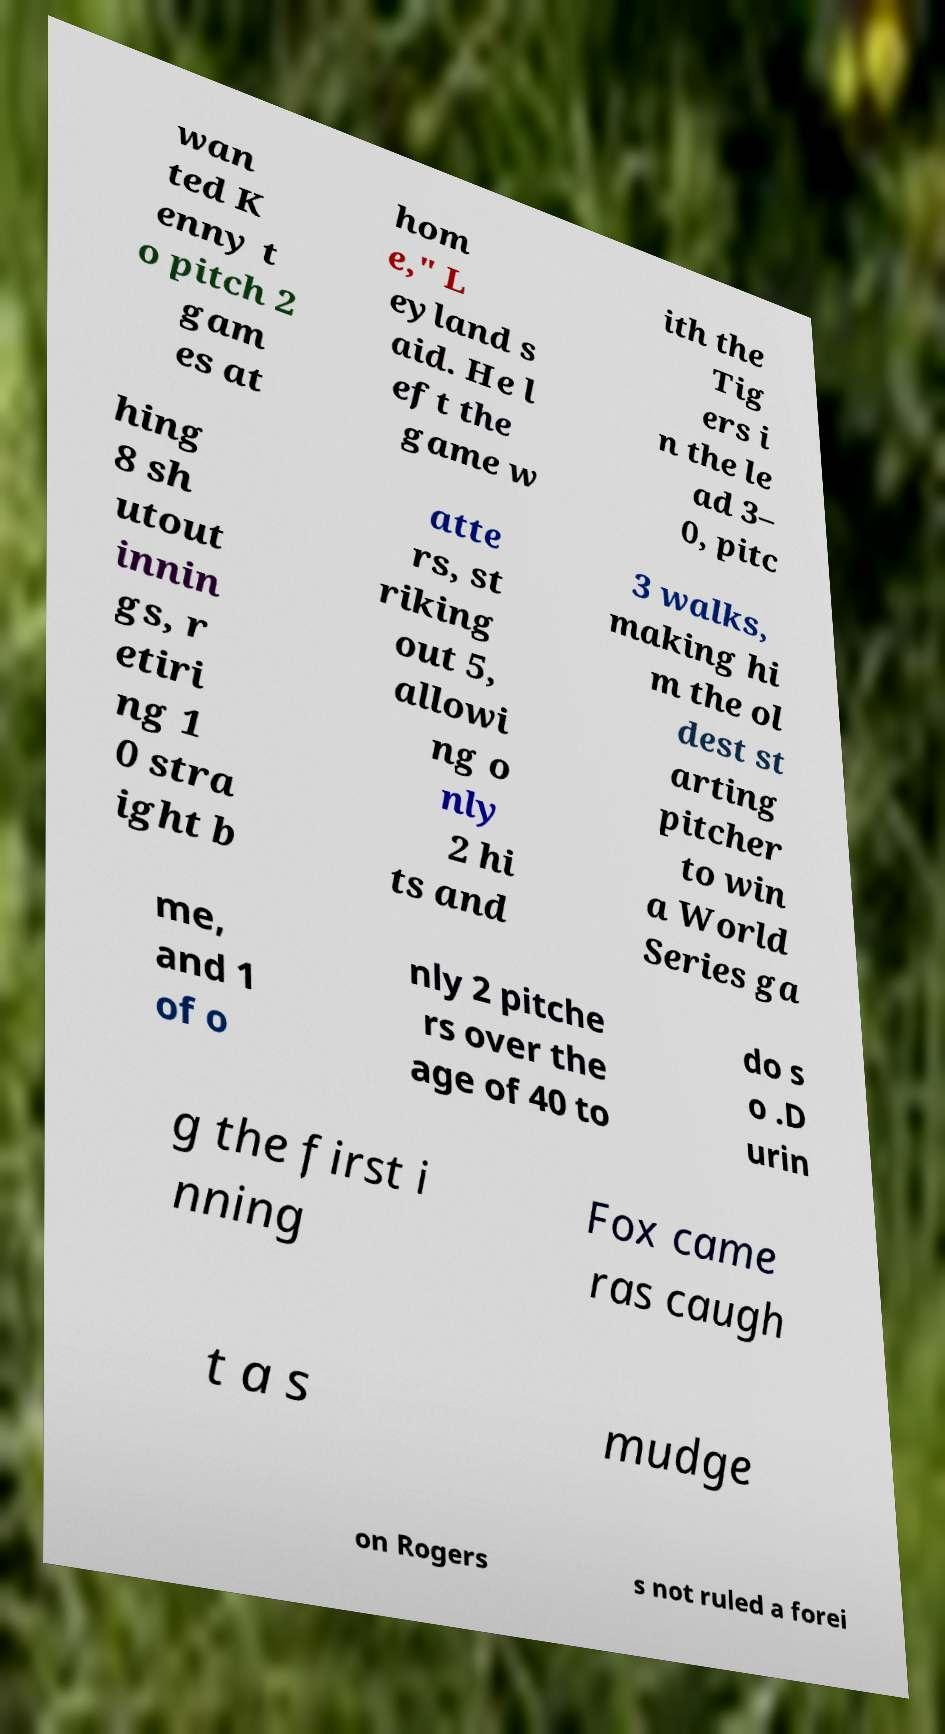Could you assist in decoding the text presented in this image and type it out clearly? wan ted K enny t o pitch 2 gam es at hom e," L eyland s aid. He l eft the game w ith the Tig ers i n the le ad 3– 0, pitc hing 8 sh utout innin gs, r etiri ng 1 0 stra ight b atte rs, st riking out 5, allowi ng o nly 2 hi ts and 3 walks, making hi m the ol dest st arting pitcher to win a World Series ga me, and 1 of o nly 2 pitche rs over the age of 40 to do s o .D urin g the first i nning Fox came ras caugh t a s mudge on Rogers s not ruled a forei 